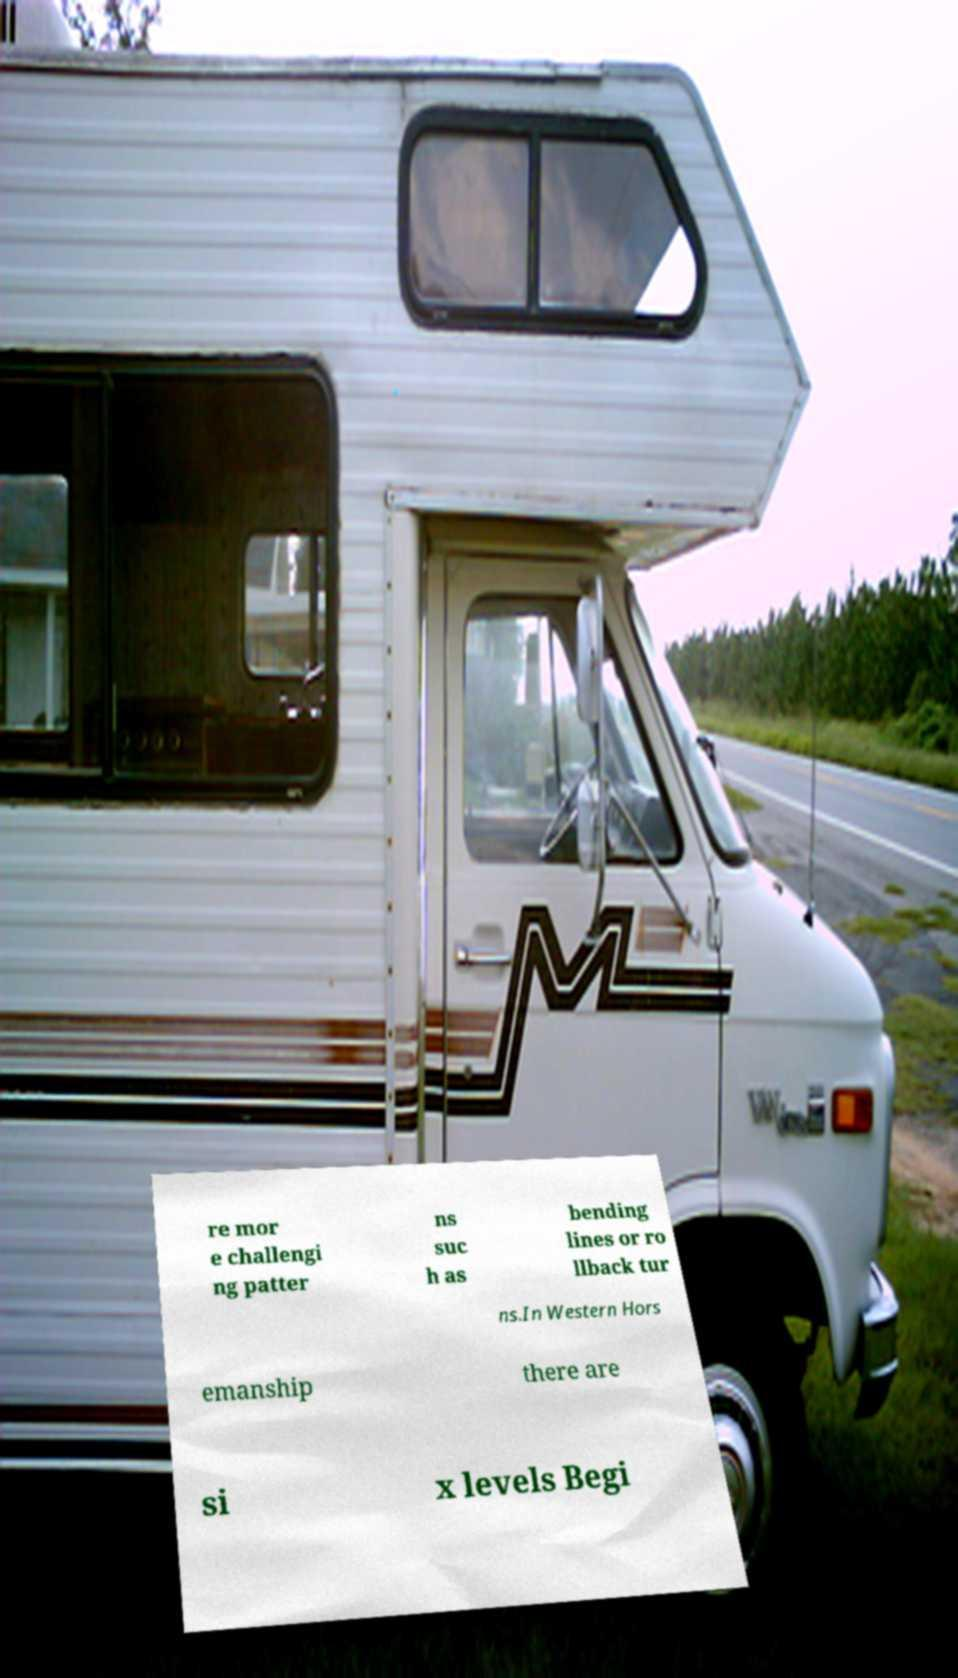Please identify and transcribe the text found in this image. re mor e challengi ng patter ns suc h as bending lines or ro llback tur ns.In Western Hors emanship there are si x levels Begi 